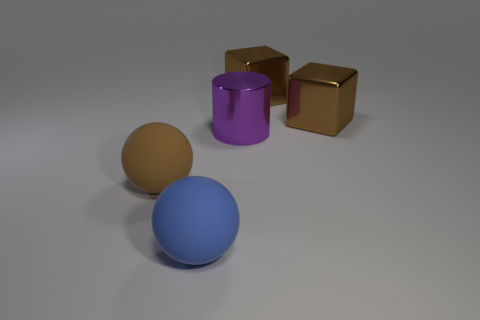Subtract all brown spheres. How many spheres are left? 1 Add 4 blue matte things. How many objects exist? 9 Subtract 0 green balls. How many objects are left? 5 Subtract all cylinders. How many objects are left? 4 Subtract all blue spheres. Subtract all blue cylinders. How many spheres are left? 1 Subtract all cyan cubes. How many yellow cylinders are left? 0 Subtract all metal balls. Subtract all large blue rubber things. How many objects are left? 4 Add 2 large brown objects. How many large brown objects are left? 5 Add 2 big purple metal cylinders. How many big purple metal cylinders exist? 3 